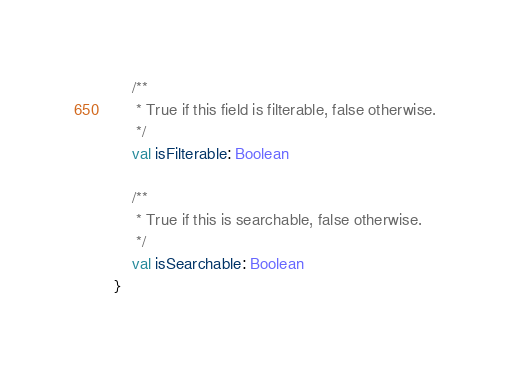Convert code to text. <code><loc_0><loc_0><loc_500><loc_500><_Kotlin_>    /**
     * True if this field is filterable, false otherwise.
     */
    val isFilterable: Boolean

    /**
     * True if this is searchable, false otherwise.
     */
    val isSearchable: Boolean
}
</code> 